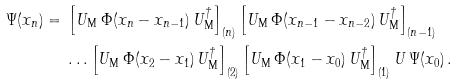Convert formula to latex. <formula><loc_0><loc_0><loc_500><loc_500>\Psi ( x _ { n } ) = \null & \null \left [ U _ { \text {M} } \, \Phi ( x _ { n } - x _ { n - 1 } ) \, U _ { \text {M} } ^ { \dagger } \right ] _ { ( n ) } \left [ U _ { \text {M} } \, \Phi ( x _ { n - 1 } - x _ { n - 2 } ) \, U _ { \text {M} } ^ { \dagger } \right ] _ { ( n - 1 ) } \\ \null & \null \dots \left [ U _ { \text {M} } \, \Phi ( x _ { 2 } - x _ { 1 } ) \, U _ { \text {M} } ^ { \dagger } \right ] _ { ( 2 ) } \left [ U _ { \text {M} } \, \Phi ( x _ { 1 } - x _ { 0 } ) \, U _ { \text {M} } ^ { \dagger } \right ] _ { ( 1 ) } U \, \Psi ( x _ { 0 } ) \, .</formula> 